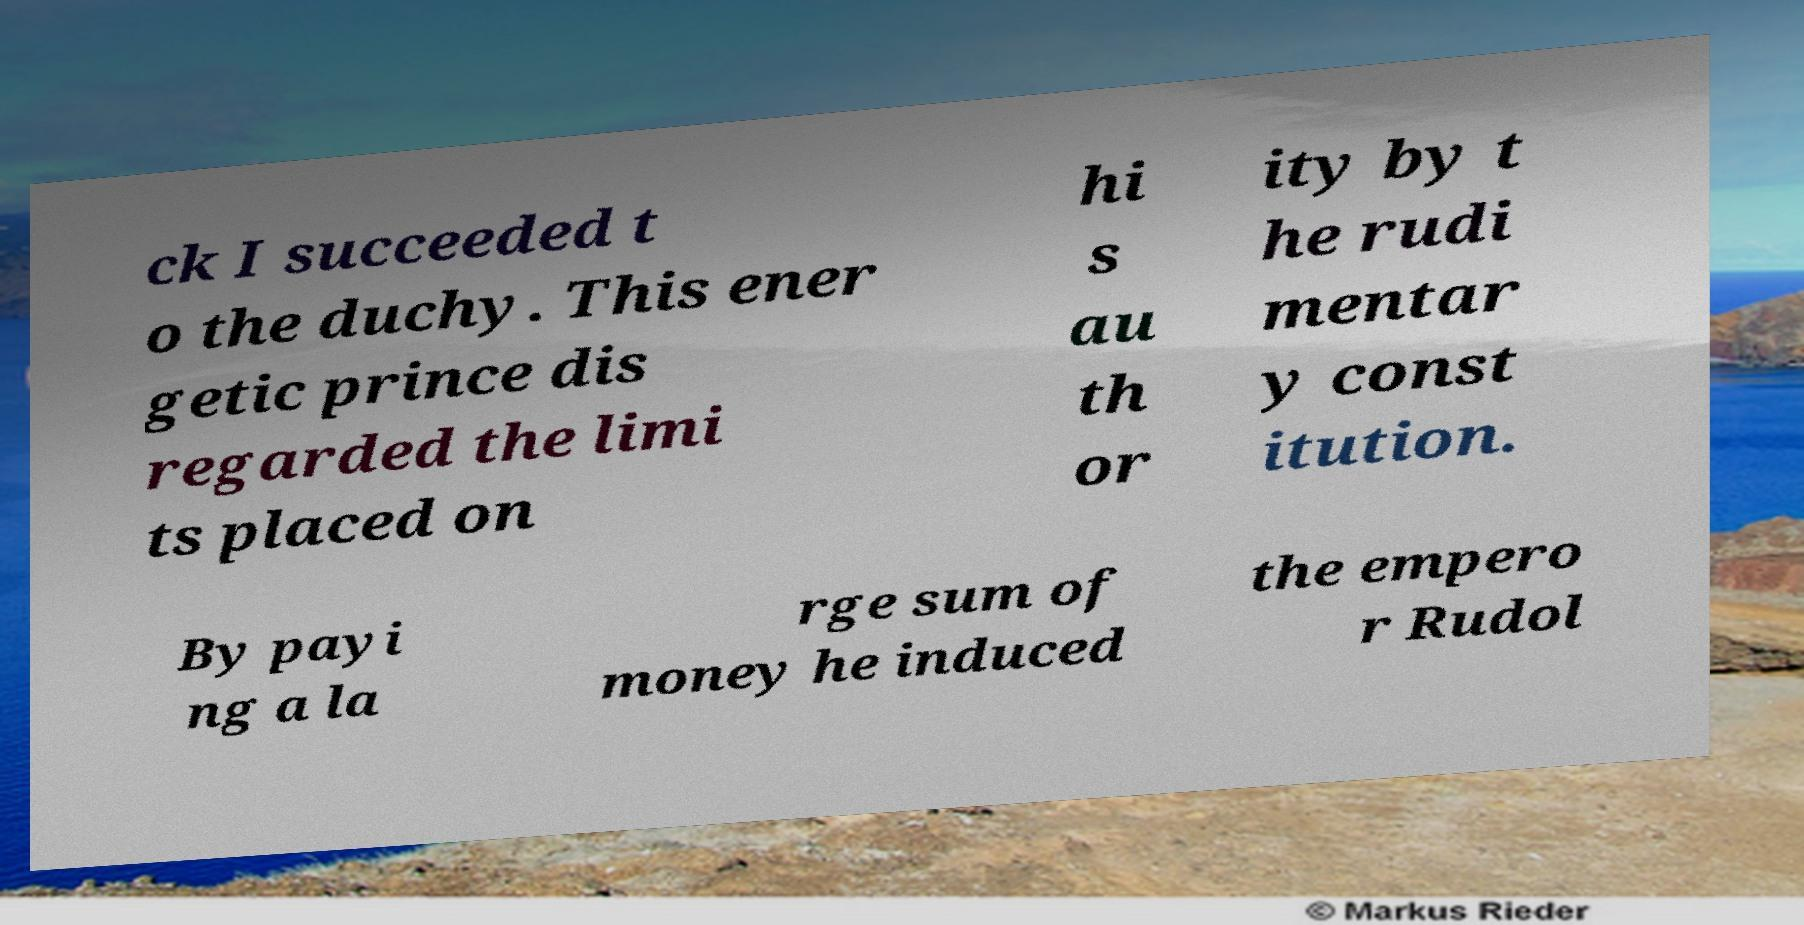Could you assist in decoding the text presented in this image and type it out clearly? ck I succeeded t o the duchy. This ener getic prince dis regarded the limi ts placed on hi s au th or ity by t he rudi mentar y const itution. By payi ng a la rge sum of money he induced the empero r Rudol 